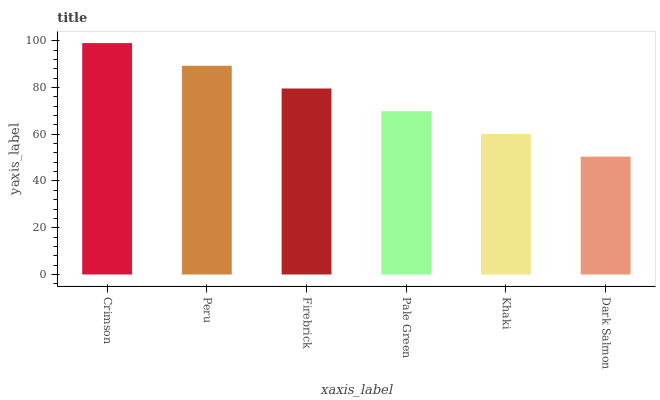Is Dark Salmon the minimum?
Answer yes or no. Yes. Is Crimson the maximum?
Answer yes or no. Yes. Is Peru the minimum?
Answer yes or no. No. Is Peru the maximum?
Answer yes or no. No. Is Crimson greater than Peru?
Answer yes or no. Yes. Is Peru less than Crimson?
Answer yes or no. Yes. Is Peru greater than Crimson?
Answer yes or no. No. Is Crimson less than Peru?
Answer yes or no. No. Is Firebrick the high median?
Answer yes or no. Yes. Is Pale Green the low median?
Answer yes or no. Yes. Is Pale Green the high median?
Answer yes or no. No. Is Khaki the low median?
Answer yes or no. No. 